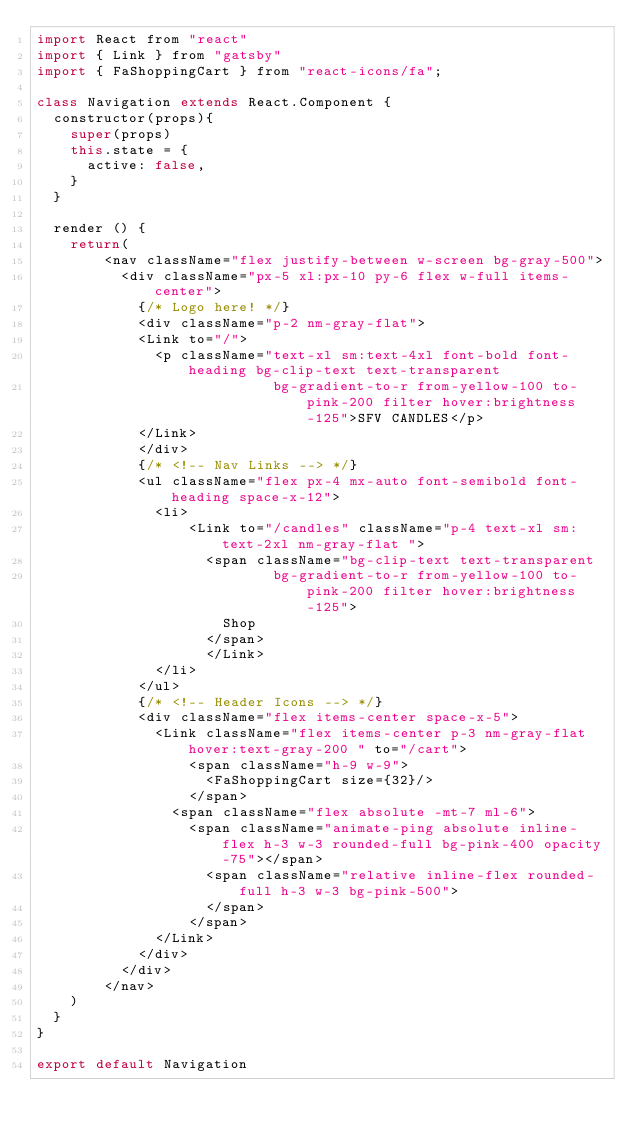Convert code to text. <code><loc_0><loc_0><loc_500><loc_500><_JavaScript_>import React from "react"
import { Link } from "gatsby"
import { FaShoppingCart } from "react-icons/fa";

class Navigation extends React.Component {
  constructor(props){
    super(props)
    this.state = {
      active: false,
    }
  }

  render () {
    return(
        <nav className="flex justify-between w-screen bg-gray-500">
          <div className="px-5 xl:px-10 py-6 flex w-full items-center">
            {/* Logo here! */}
            <div className="p-2 nm-gray-flat">
            <Link to="/">
              <p className="text-xl sm:text-4xl font-bold font-heading bg-clip-text text-transparent 
                            bg-gradient-to-r from-yellow-100 to-pink-200 filter hover:brightness-125">SFV CANDLES</p>
            </Link>
            </div>
            {/* <!-- Nav Links --> */}
            <ul className="flex px-4 mx-auto font-semibold font-heading space-x-12">
              <li>
                  <Link to="/candles" className="p-4 text-xl sm:text-2xl nm-gray-flat ">
                    <span className="bg-clip-text text-transparent 
                            bg-gradient-to-r from-yellow-100 to-pink-200 filter hover:brightness-125">
                      Shop
                    </span>
                    </Link>
              </li>
            </ul>
            {/* <!-- Header Icons --> */}
            <div className="flex items-center space-x-5">
              <Link className="flex items-center p-3 nm-gray-flat hover:text-gray-200 " to="/cart">
                  <span className="h-9 w-9">
                    <FaShoppingCart size={32}/>
                  </span>
                <span className="flex absolute -mt-7 ml-6">
                  <span className="animate-ping absolute inline-flex h-3 w-3 rounded-full bg-pink-400 opacity-75"></span>
                    <span className="relative inline-flex rounded-full h-3 w-3 bg-pink-500">
                    </span>
                  </span>
              </Link>
            </div>
          </div>
        </nav>
    ) 
  }
}

export default Navigation
</code> 